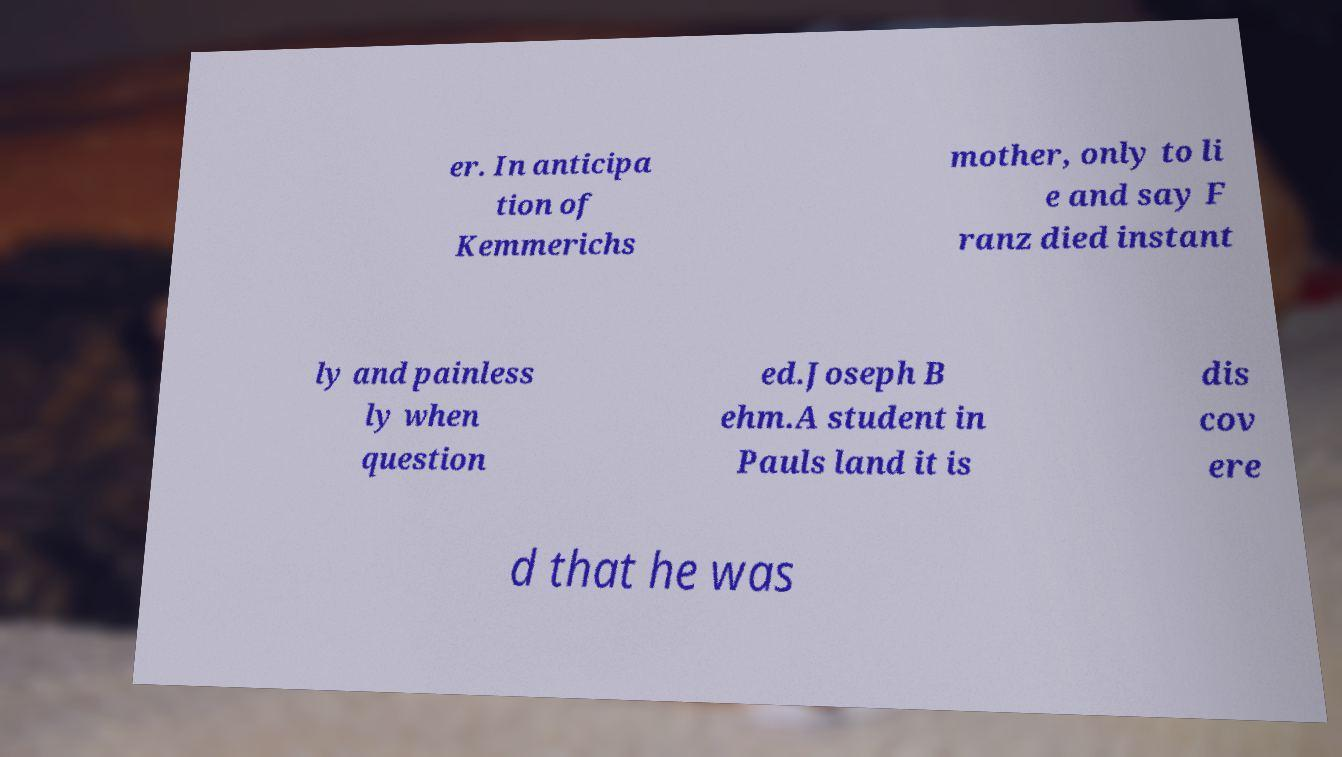Please read and relay the text visible in this image. What does it say? er. In anticipa tion of Kemmerichs mother, only to li e and say F ranz died instant ly and painless ly when question ed.Joseph B ehm.A student in Pauls land it is dis cov ere d that he was 